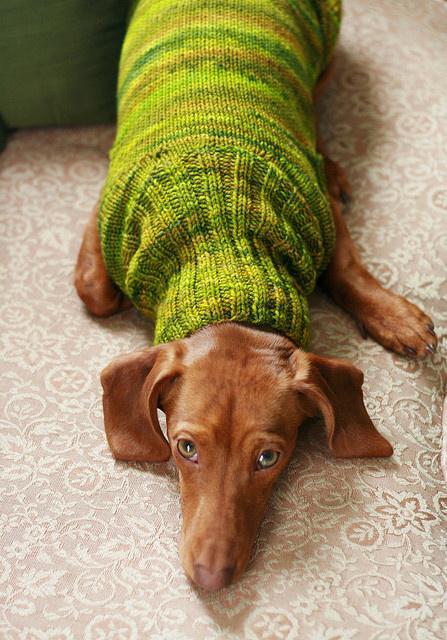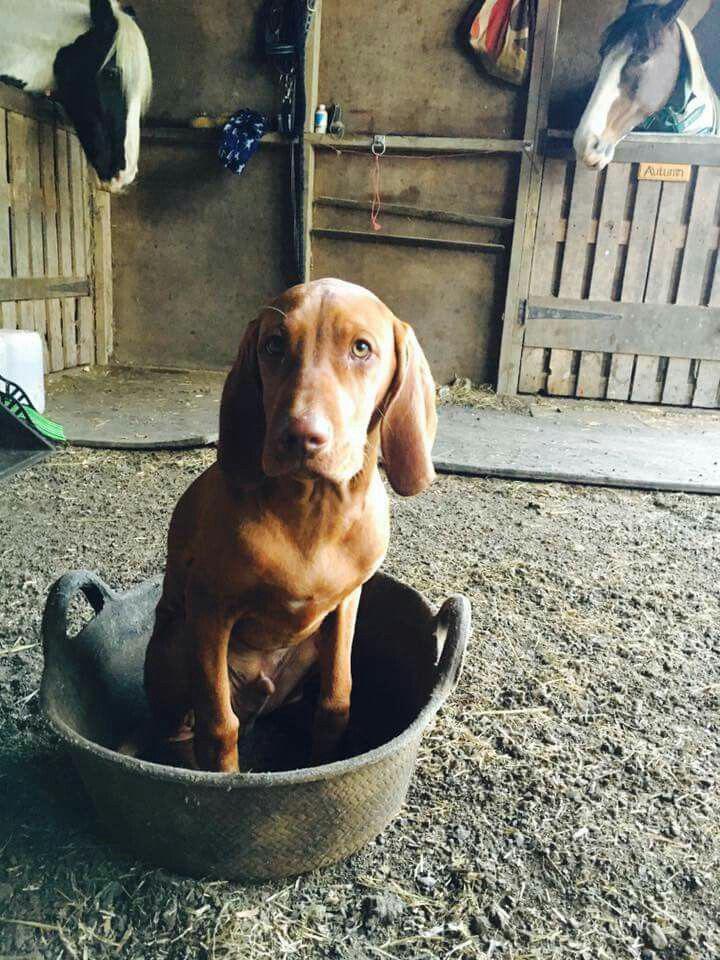The first image is the image on the left, the second image is the image on the right. For the images shown, is this caption "One dog is wearing a turtleneck shirt." true? Answer yes or no. Yes. The first image is the image on the left, the second image is the image on the right. Assess this claim about the two images: "The dog on the right is reclining with front paws stretched in front of him and head raised, and the dog on the left is sitting uprgiht and wearing a pullover top.". Correct or not? Answer yes or no. No. 